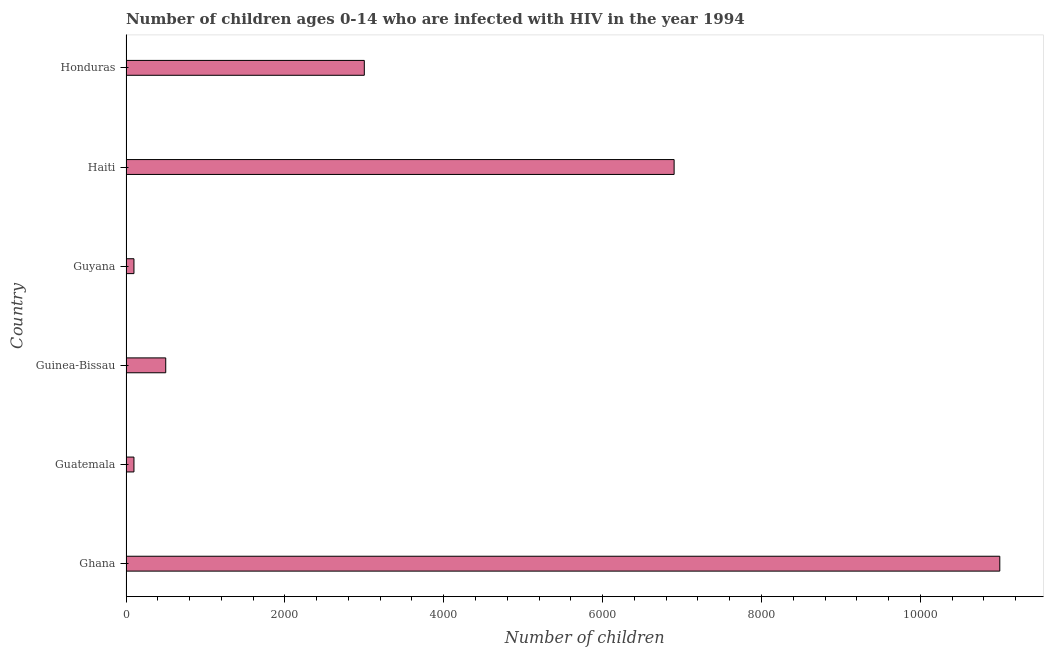What is the title of the graph?
Provide a short and direct response. Number of children ages 0-14 who are infected with HIV in the year 1994. What is the label or title of the X-axis?
Make the answer very short. Number of children. What is the number of children living with hiv in Honduras?
Offer a terse response. 3000. Across all countries, what is the maximum number of children living with hiv?
Your response must be concise. 1.10e+04. In which country was the number of children living with hiv minimum?
Offer a very short reply. Guatemala. What is the sum of the number of children living with hiv?
Provide a succinct answer. 2.16e+04. What is the difference between the number of children living with hiv in Guyana and Haiti?
Offer a terse response. -6800. What is the average number of children living with hiv per country?
Your answer should be compact. 3600. What is the median number of children living with hiv?
Ensure brevity in your answer.  1750. In how many countries, is the number of children living with hiv greater than 2400 ?
Keep it short and to the point. 3. Is the number of children living with hiv in Ghana less than that in Guyana?
Offer a terse response. No. Is the difference between the number of children living with hiv in Guatemala and Guyana greater than the difference between any two countries?
Your response must be concise. No. What is the difference between the highest and the second highest number of children living with hiv?
Offer a terse response. 4100. What is the difference between the highest and the lowest number of children living with hiv?
Offer a terse response. 1.09e+04. How many bars are there?
Ensure brevity in your answer.  6. What is the difference between two consecutive major ticks on the X-axis?
Your response must be concise. 2000. What is the Number of children of Ghana?
Keep it short and to the point. 1.10e+04. What is the Number of children of Guinea-Bissau?
Offer a very short reply. 500. What is the Number of children in Haiti?
Provide a short and direct response. 6900. What is the Number of children of Honduras?
Your answer should be very brief. 3000. What is the difference between the Number of children in Ghana and Guatemala?
Provide a short and direct response. 1.09e+04. What is the difference between the Number of children in Ghana and Guinea-Bissau?
Keep it short and to the point. 1.05e+04. What is the difference between the Number of children in Ghana and Guyana?
Make the answer very short. 1.09e+04. What is the difference between the Number of children in Ghana and Haiti?
Provide a succinct answer. 4100. What is the difference between the Number of children in Ghana and Honduras?
Your response must be concise. 8000. What is the difference between the Number of children in Guatemala and Guinea-Bissau?
Your answer should be compact. -400. What is the difference between the Number of children in Guatemala and Haiti?
Keep it short and to the point. -6800. What is the difference between the Number of children in Guatemala and Honduras?
Ensure brevity in your answer.  -2900. What is the difference between the Number of children in Guinea-Bissau and Haiti?
Your answer should be very brief. -6400. What is the difference between the Number of children in Guinea-Bissau and Honduras?
Offer a terse response. -2500. What is the difference between the Number of children in Guyana and Haiti?
Ensure brevity in your answer.  -6800. What is the difference between the Number of children in Guyana and Honduras?
Provide a succinct answer. -2900. What is the difference between the Number of children in Haiti and Honduras?
Ensure brevity in your answer.  3900. What is the ratio of the Number of children in Ghana to that in Guatemala?
Provide a succinct answer. 110. What is the ratio of the Number of children in Ghana to that in Guinea-Bissau?
Provide a succinct answer. 22. What is the ratio of the Number of children in Ghana to that in Guyana?
Ensure brevity in your answer.  110. What is the ratio of the Number of children in Ghana to that in Haiti?
Your response must be concise. 1.59. What is the ratio of the Number of children in Ghana to that in Honduras?
Provide a short and direct response. 3.67. What is the ratio of the Number of children in Guatemala to that in Guinea-Bissau?
Make the answer very short. 0.2. What is the ratio of the Number of children in Guatemala to that in Guyana?
Your response must be concise. 1. What is the ratio of the Number of children in Guatemala to that in Haiti?
Offer a terse response. 0.01. What is the ratio of the Number of children in Guatemala to that in Honduras?
Provide a short and direct response. 0.03. What is the ratio of the Number of children in Guinea-Bissau to that in Guyana?
Provide a short and direct response. 5. What is the ratio of the Number of children in Guinea-Bissau to that in Haiti?
Make the answer very short. 0.07. What is the ratio of the Number of children in Guinea-Bissau to that in Honduras?
Provide a succinct answer. 0.17. What is the ratio of the Number of children in Guyana to that in Haiti?
Give a very brief answer. 0.01. What is the ratio of the Number of children in Guyana to that in Honduras?
Provide a short and direct response. 0.03. 